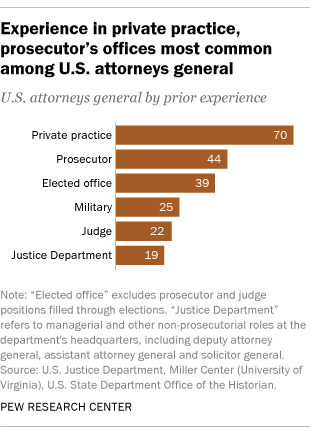Outline some significant characteristics in this image. The Justice Department represents the least value. 